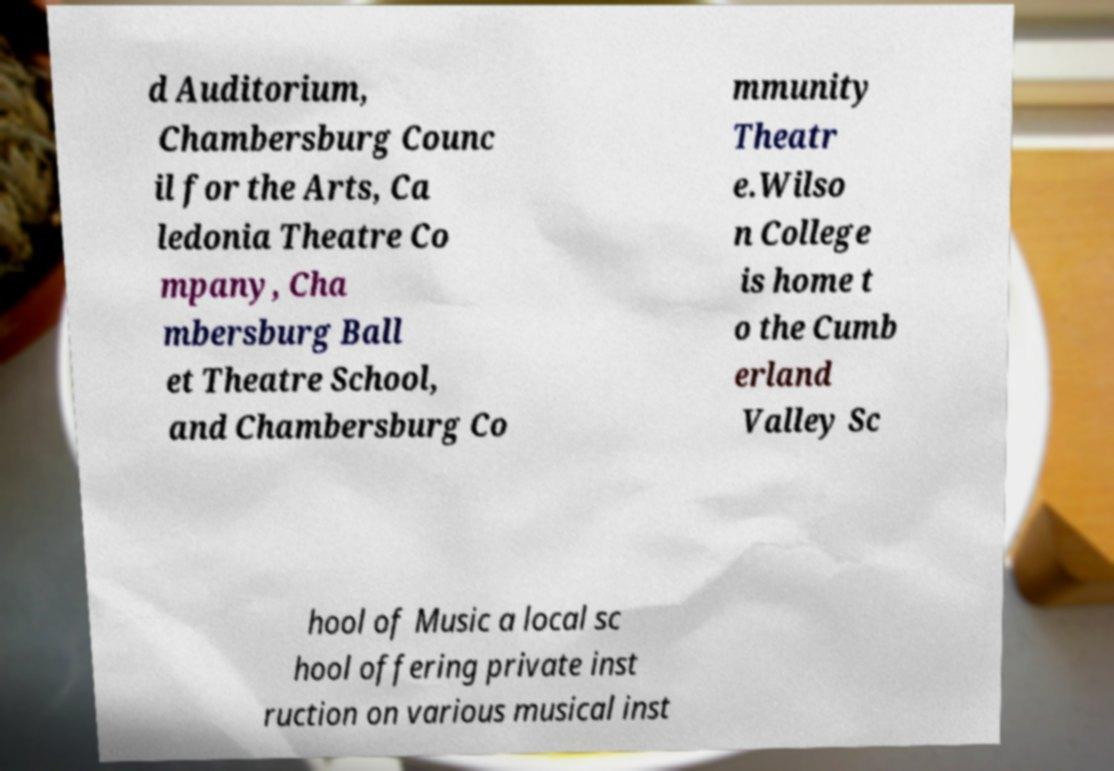Could you assist in decoding the text presented in this image and type it out clearly? d Auditorium, Chambersburg Counc il for the Arts, Ca ledonia Theatre Co mpany, Cha mbersburg Ball et Theatre School, and Chambersburg Co mmunity Theatr e.Wilso n College is home t o the Cumb erland Valley Sc hool of Music a local sc hool offering private inst ruction on various musical inst 